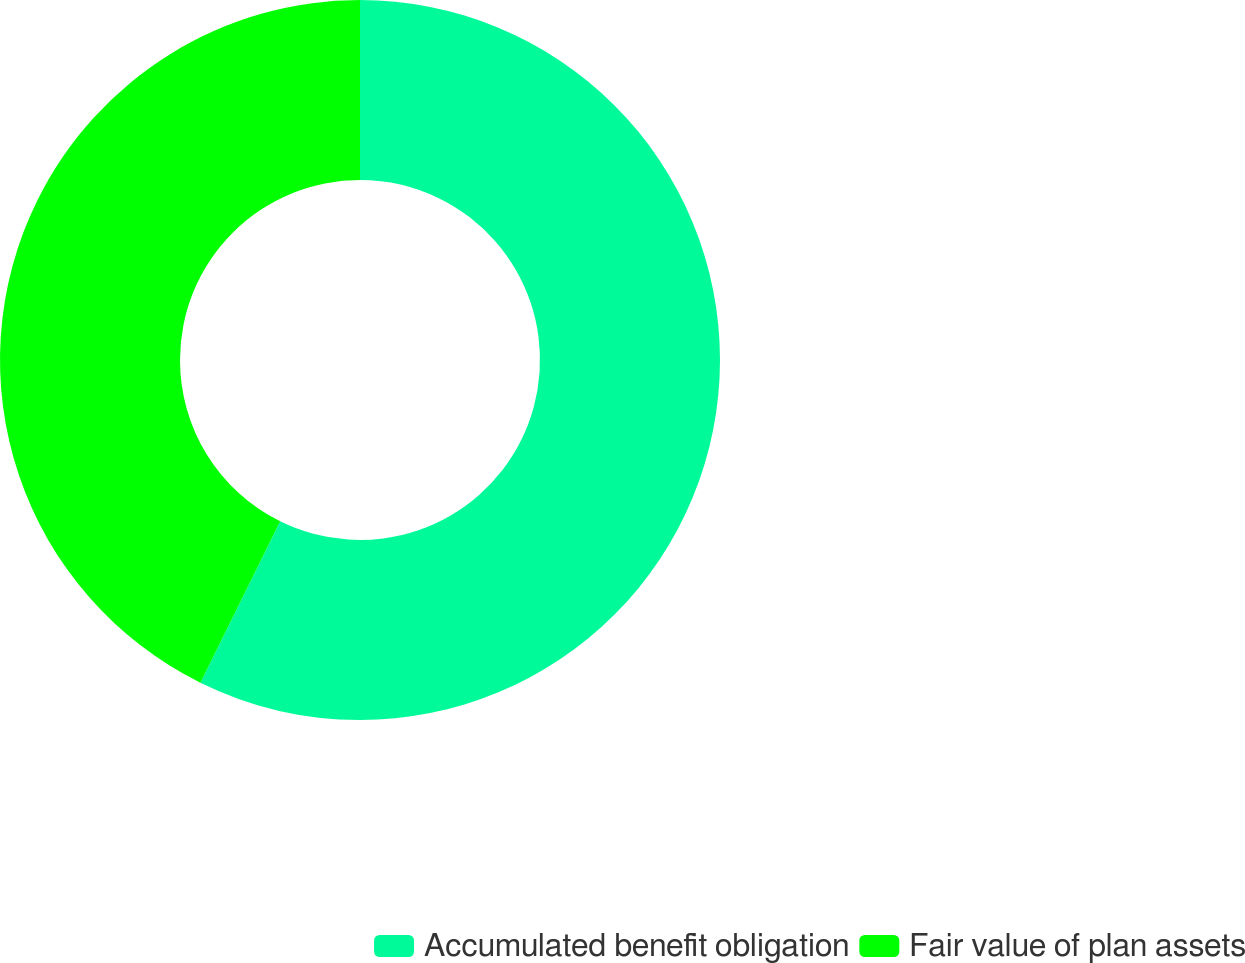Convert chart to OTSL. <chart><loc_0><loc_0><loc_500><loc_500><pie_chart><fcel>Accumulated benefit obligation<fcel>Fair value of plan assets<nl><fcel>57.31%<fcel>42.69%<nl></chart> 